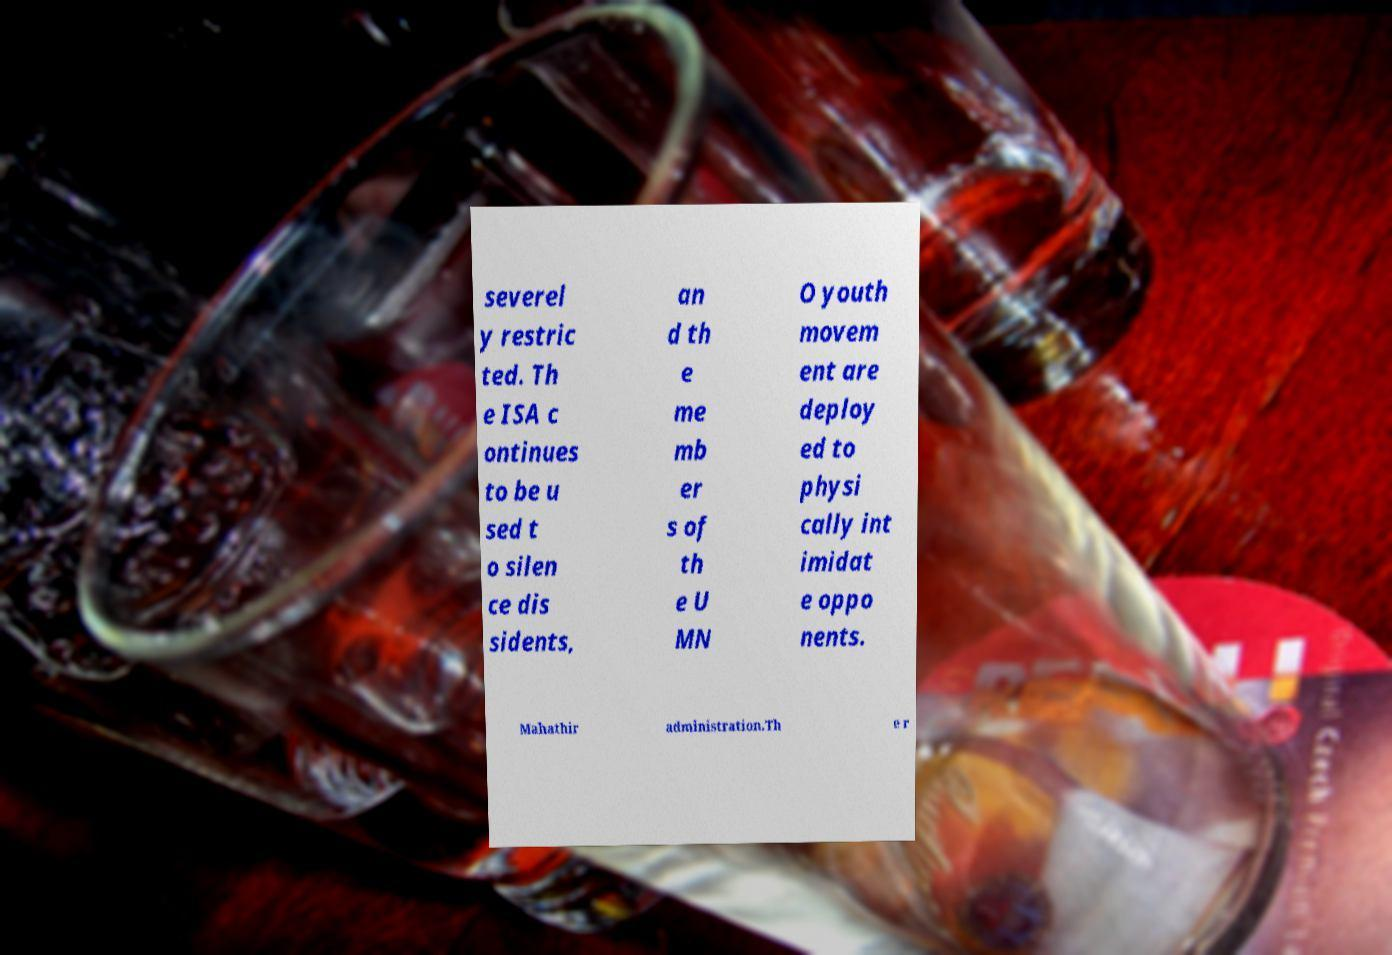For documentation purposes, I need the text within this image transcribed. Could you provide that? severel y restric ted. Th e ISA c ontinues to be u sed t o silen ce dis sidents, an d th e me mb er s of th e U MN O youth movem ent are deploy ed to physi cally int imidat e oppo nents. Mahathir administration.Th e r 